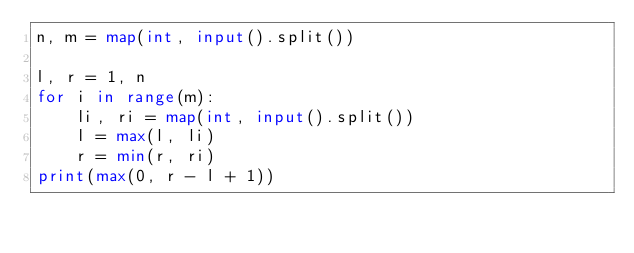Convert code to text. <code><loc_0><loc_0><loc_500><loc_500><_Python_>n, m = map(int, input().split())

l, r = 1, n
for i in range(m):
    li, ri = map(int, input().split())
    l = max(l, li)
    r = min(r, ri)
print(max(0, r - l + 1))</code> 